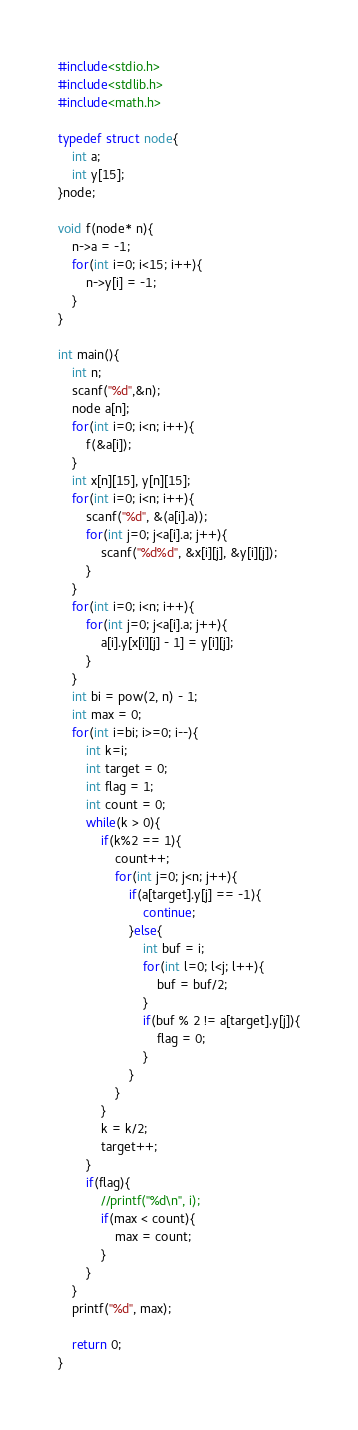Convert code to text. <code><loc_0><loc_0><loc_500><loc_500><_C_>#include<stdio.h>
#include<stdlib.h>
#include<math.h>

typedef struct node{
    int a;
    int y[15];
}node;

void f(node* n){
    n->a = -1;
    for(int i=0; i<15; i++){
        n->y[i] = -1;
    }
}

int main(){
    int n;
    scanf("%d",&n);
    node a[n];
    for(int i=0; i<n; i++){
        f(&a[i]);
    }
    int x[n][15], y[n][15];
    for(int i=0; i<n; i++){
        scanf("%d", &(a[i].a));
        for(int j=0; j<a[i].a; j++){
            scanf("%d%d", &x[i][j], &y[i][j]);
        }
    }
    for(int i=0; i<n; i++){
        for(int j=0; j<a[i].a; j++){
            a[i].y[x[i][j] - 1] = y[i][j];
        }
    }
    int bi = pow(2, n) - 1;
    int max = 0;
    for(int i=bi; i>=0; i--){
        int k=i;
        int target = 0;
        int flag = 1;
        int count = 0;
        while(k > 0){
            if(k%2 == 1){
                count++;
                for(int j=0; j<n; j++){
                    if(a[target].y[j] == -1){
                        continue;
                    }else{
                        int buf = i;
                        for(int l=0; l<j; l++){
                            buf = buf/2;
                        }
                        if(buf % 2 != a[target].y[j]){
                            flag = 0;
                        }
                    }
                }
            }
            k = k/2;
            target++;
        }
        if(flag){
            //printf("%d\n", i);
            if(max < count){
                max = count;
            }
        }
    }
    printf("%d", max);

    return 0;
}</code> 